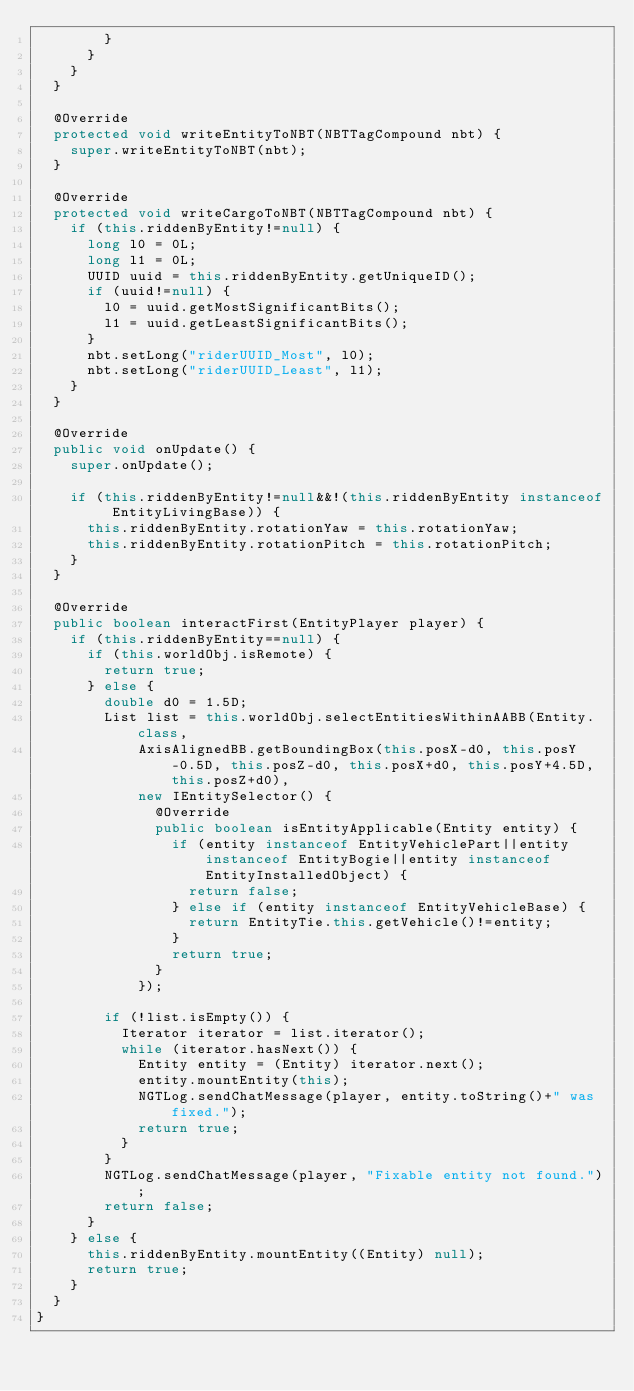<code> <loc_0><loc_0><loc_500><loc_500><_Java_>				}
			}
		}
	}

	@Override
	protected void writeEntityToNBT(NBTTagCompound nbt) {
		super.writeEntityToNBT(nbt);
	}

	@Override
	protected void writeCargoToNBT(NBTTagCompound nbt) {
		if (this.riddenByEntity!=null) {
			long l0 = 0L;
			long l1 = 0L;
			UUID uuid = this.riddenByEntity.getUniqueID();
			if (uuid!=null) {
				l0 = uuid.getMostSignificantBits();
				l1 = uuid.getLeastSignificantBits();
			}
			nbt.setLong("riderUUID_Most", l0);
			nbt.setLong("riderUUID_Least", l1);
		}
	}

	@Override
	public void onUpdate() {
		super.onUpdate();

		if (this.riddenByEntity!=null&&!(this.riddenByEntity instanceof EntityLivingBase)) {
			this.riddenByEntity.rotationYaw = this.rotationYaw;
			this.riddenByEntity.rotationPitch = this.rotationPitch;
		}
	}

	@Override
	public boolean interactFirst(EntityPlayer player) {
		if (this.riddenByEntity==null) {
			if (this.worldObj.isRemote) {
				return true;
			} else {
				double d0 = 1.5D;
				List list = this.worldObj.selectEntitiesWithinAABB(Entity.class,
						AxisAlignedBB.getBoundingBox(this.posX-d0, this.posY-0.5D, this.posZ-d0, this.posX+d0, this.posY+4.5D, this.posZ+d0),
						new IEntitySelector() {
							@Override
							public boolean isEntityApplicable(Entity entity) {
								if (entity instanceof EntityVehiclePart||entity instanceof EntityBogie||entity instanceof EntityInstalledObject) {
									return false;
								} else if (entity instanceof EntityVehicleBase) {
									return EntityTie.this.getVehicle()!=entity;
								}
								return true;
							}
						});

				if (!list.isEmpty()) {
					Iterator iterator = list.iterator();
					while (iterator.hasNext()) {
						Entity entity = (Entity) iterator.next();
						entity.mountEntity(this);
						NGTLog.sendChatMessage(player, entity.toString()+" was fixed.");
						return true;
					}
				}
				NGTLog.sendChatMessage(player, "Fixable entity not found.");
				return false;
			}
		} else {
			this.riddenByEntity.mountEntity((Entity) null);
			return true;
		}
	}
}</code> 